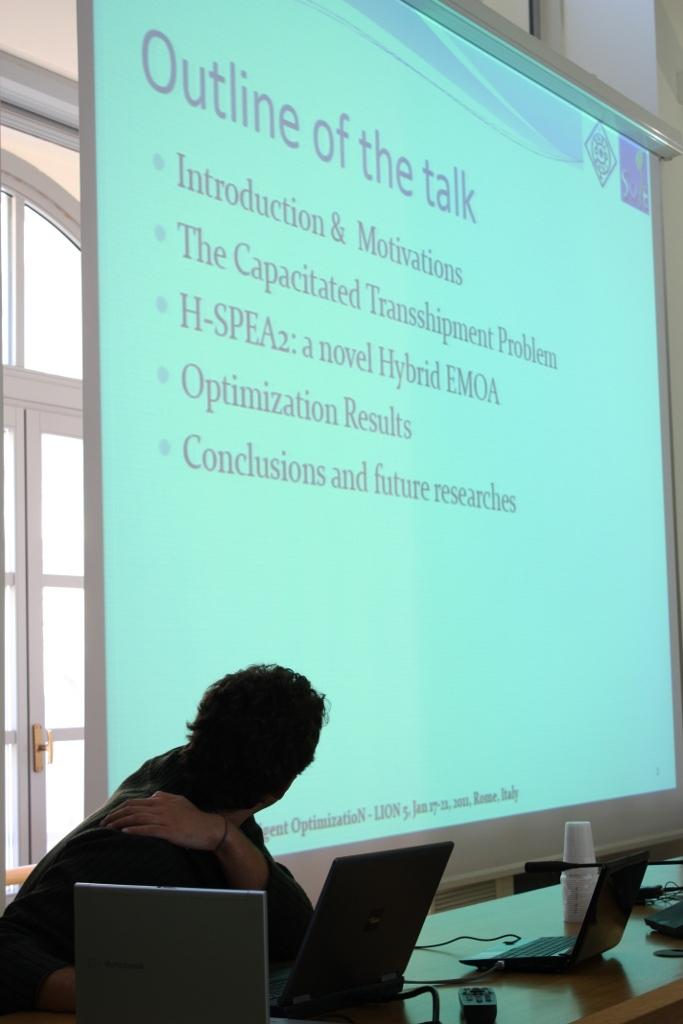What is the title of the outline page?
Make the answer very short. Outline of the talk. What kind of problem is the second bullet point?
Your answer should be compact. The capacitated transshipment problem. 